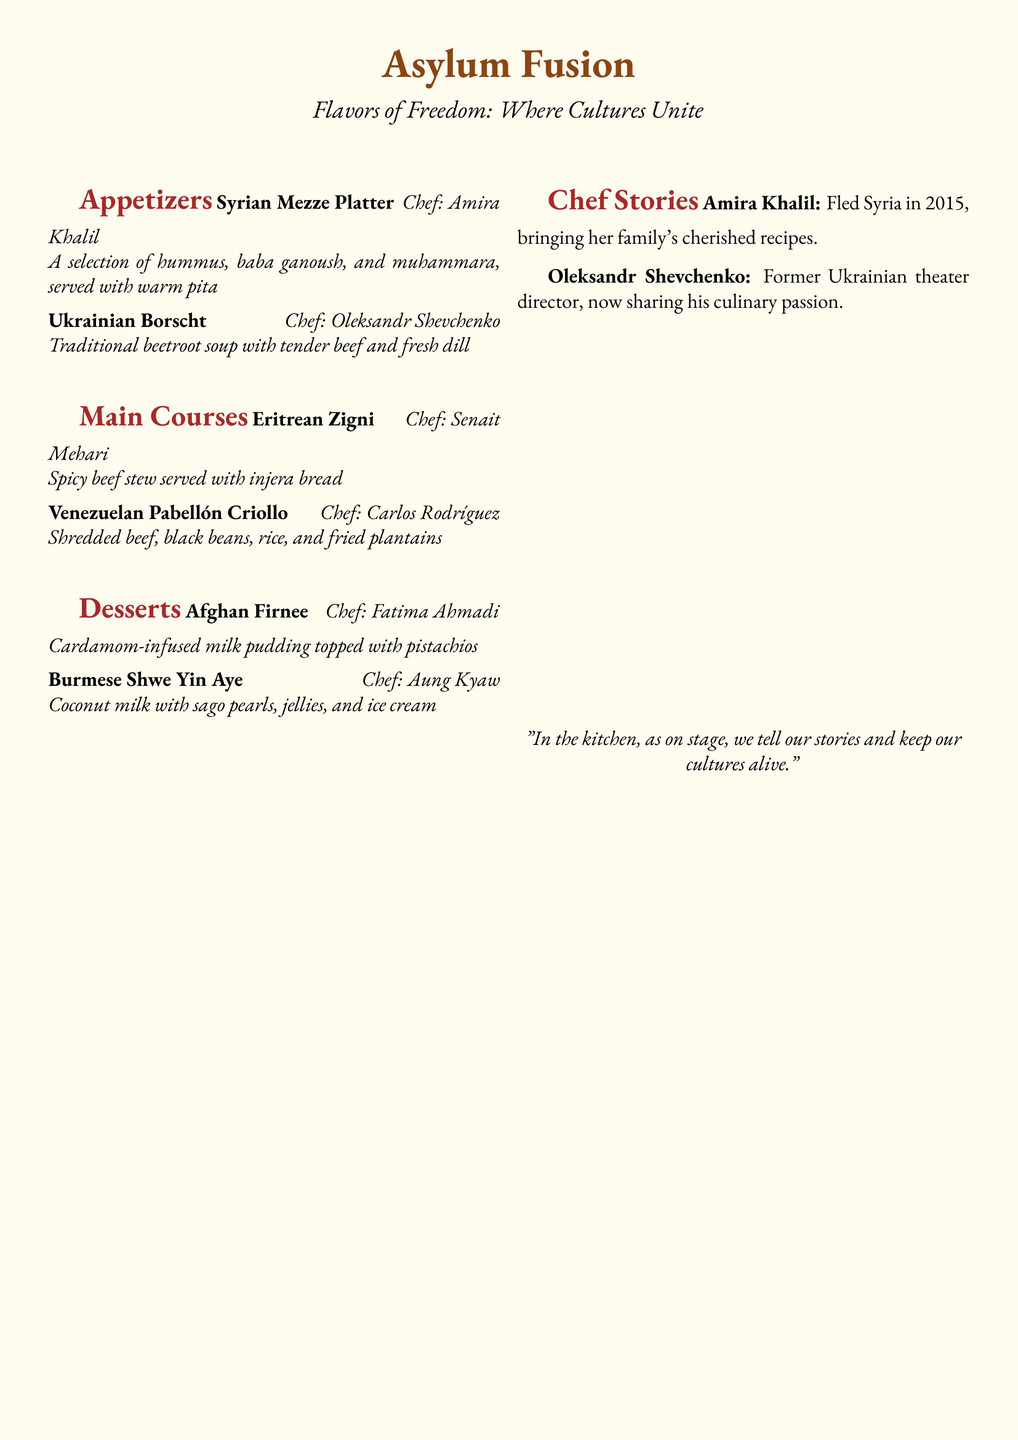What is the name of the restaurant? The restaurant is named "Asylum Fusion," which is stated at the top of the menu document.
Answer: Asylum Fusion Who is the chef for the Syrian Mezze Platter? The chef for the Syrian Mezze Platter is Amira Khalil, specified under the menu item.
Answer: Amira Khalil How many main courses are listed in the menu? There are two main courses listed in the menu, as seen in the main courses section.
Answer: 2 What is the main ingredient in Ukrainian Borscht? The main ingredient in Ukrainian Borscht is beetroot, as indicated in the description.
Answer: Beetroot Which dessert is topped with pistachios? The dessert topped with pistachios is Afghan Firnee, according to the dessert section.
Answer: Afghan Firnee Who fled Syria in 2015? Amira Khalil fled Syria in 2015, as shared in the chef stories section.
Answer: Amira Khalil What genre of culinary creation is emphasized in the menu's introductory statement? The introductory statement emphasizes "cultural diversity," highlighting the theme of the menu.
Answer: Cultural diversity Which country does the chef of Eritrean Zigni come from? The chef of Eritrean Zigni, Senait Mehari, comes from Eritrea, indicated next to the main course.
Answer: Eritrea What is the flavor profile of Burmese Shwe Yin Aye? Burmese Shwe Yin Aye has a flavor profile that includes coconut milk, as described in the dessert section.
Answer: Coconut milk 